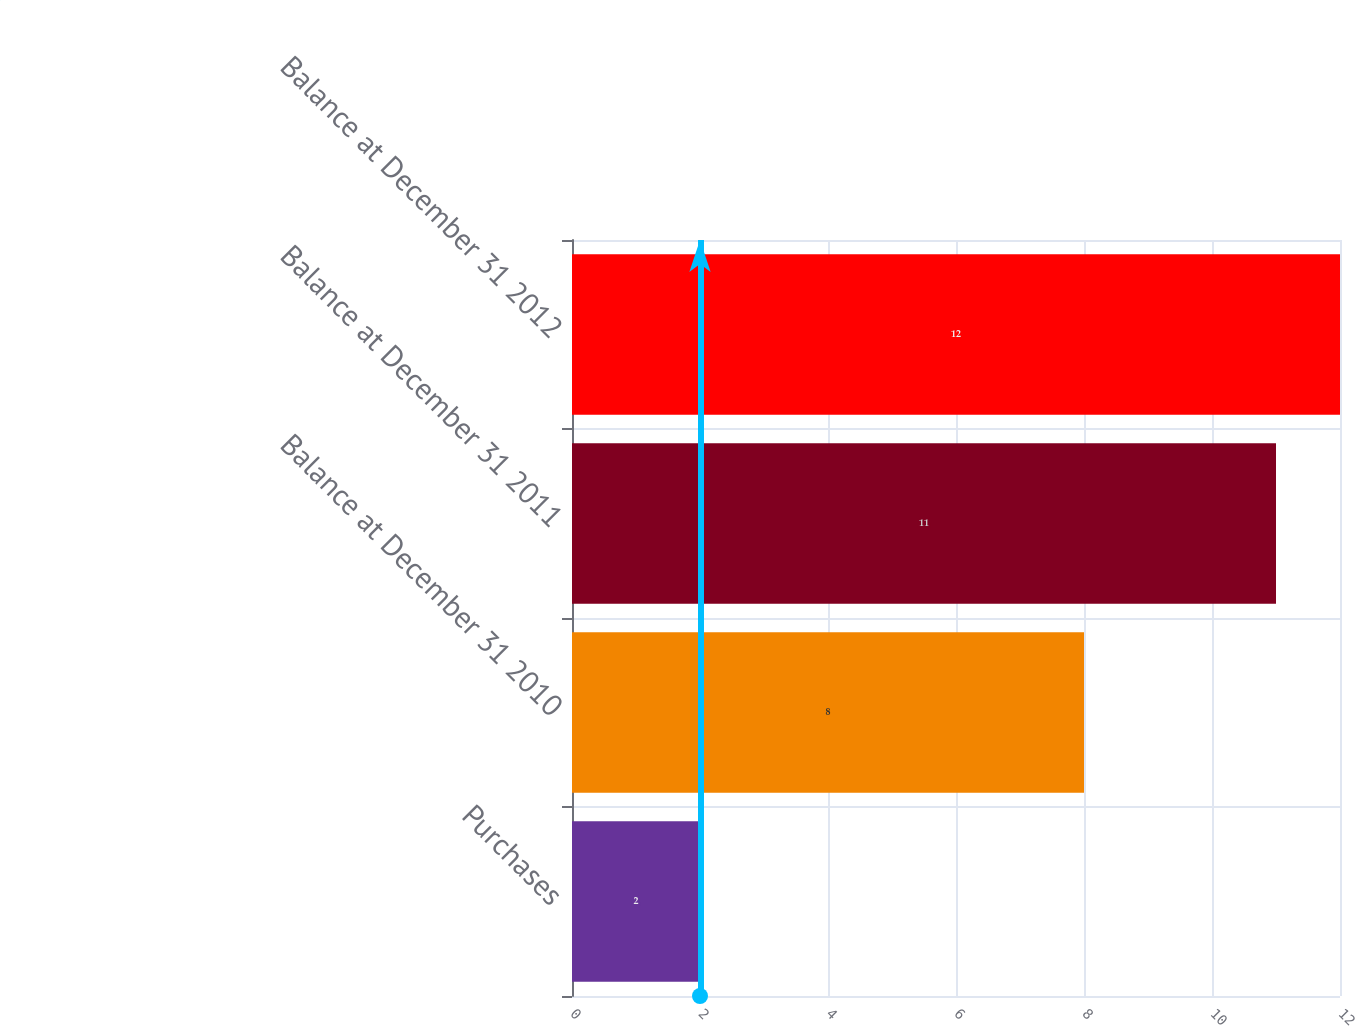Convert chart to OTSL. <chart><loc_0><loc_0><loc_500><loc_500><bar_chart><fcel>Purchases<fcel>Balance at December 31 2010<fcel>Balance at December 31 2011<fcel>Balance at December 31 2012<nl><fcel>2<fcel>8<fcel>11<fcel>12<nl></chart> 